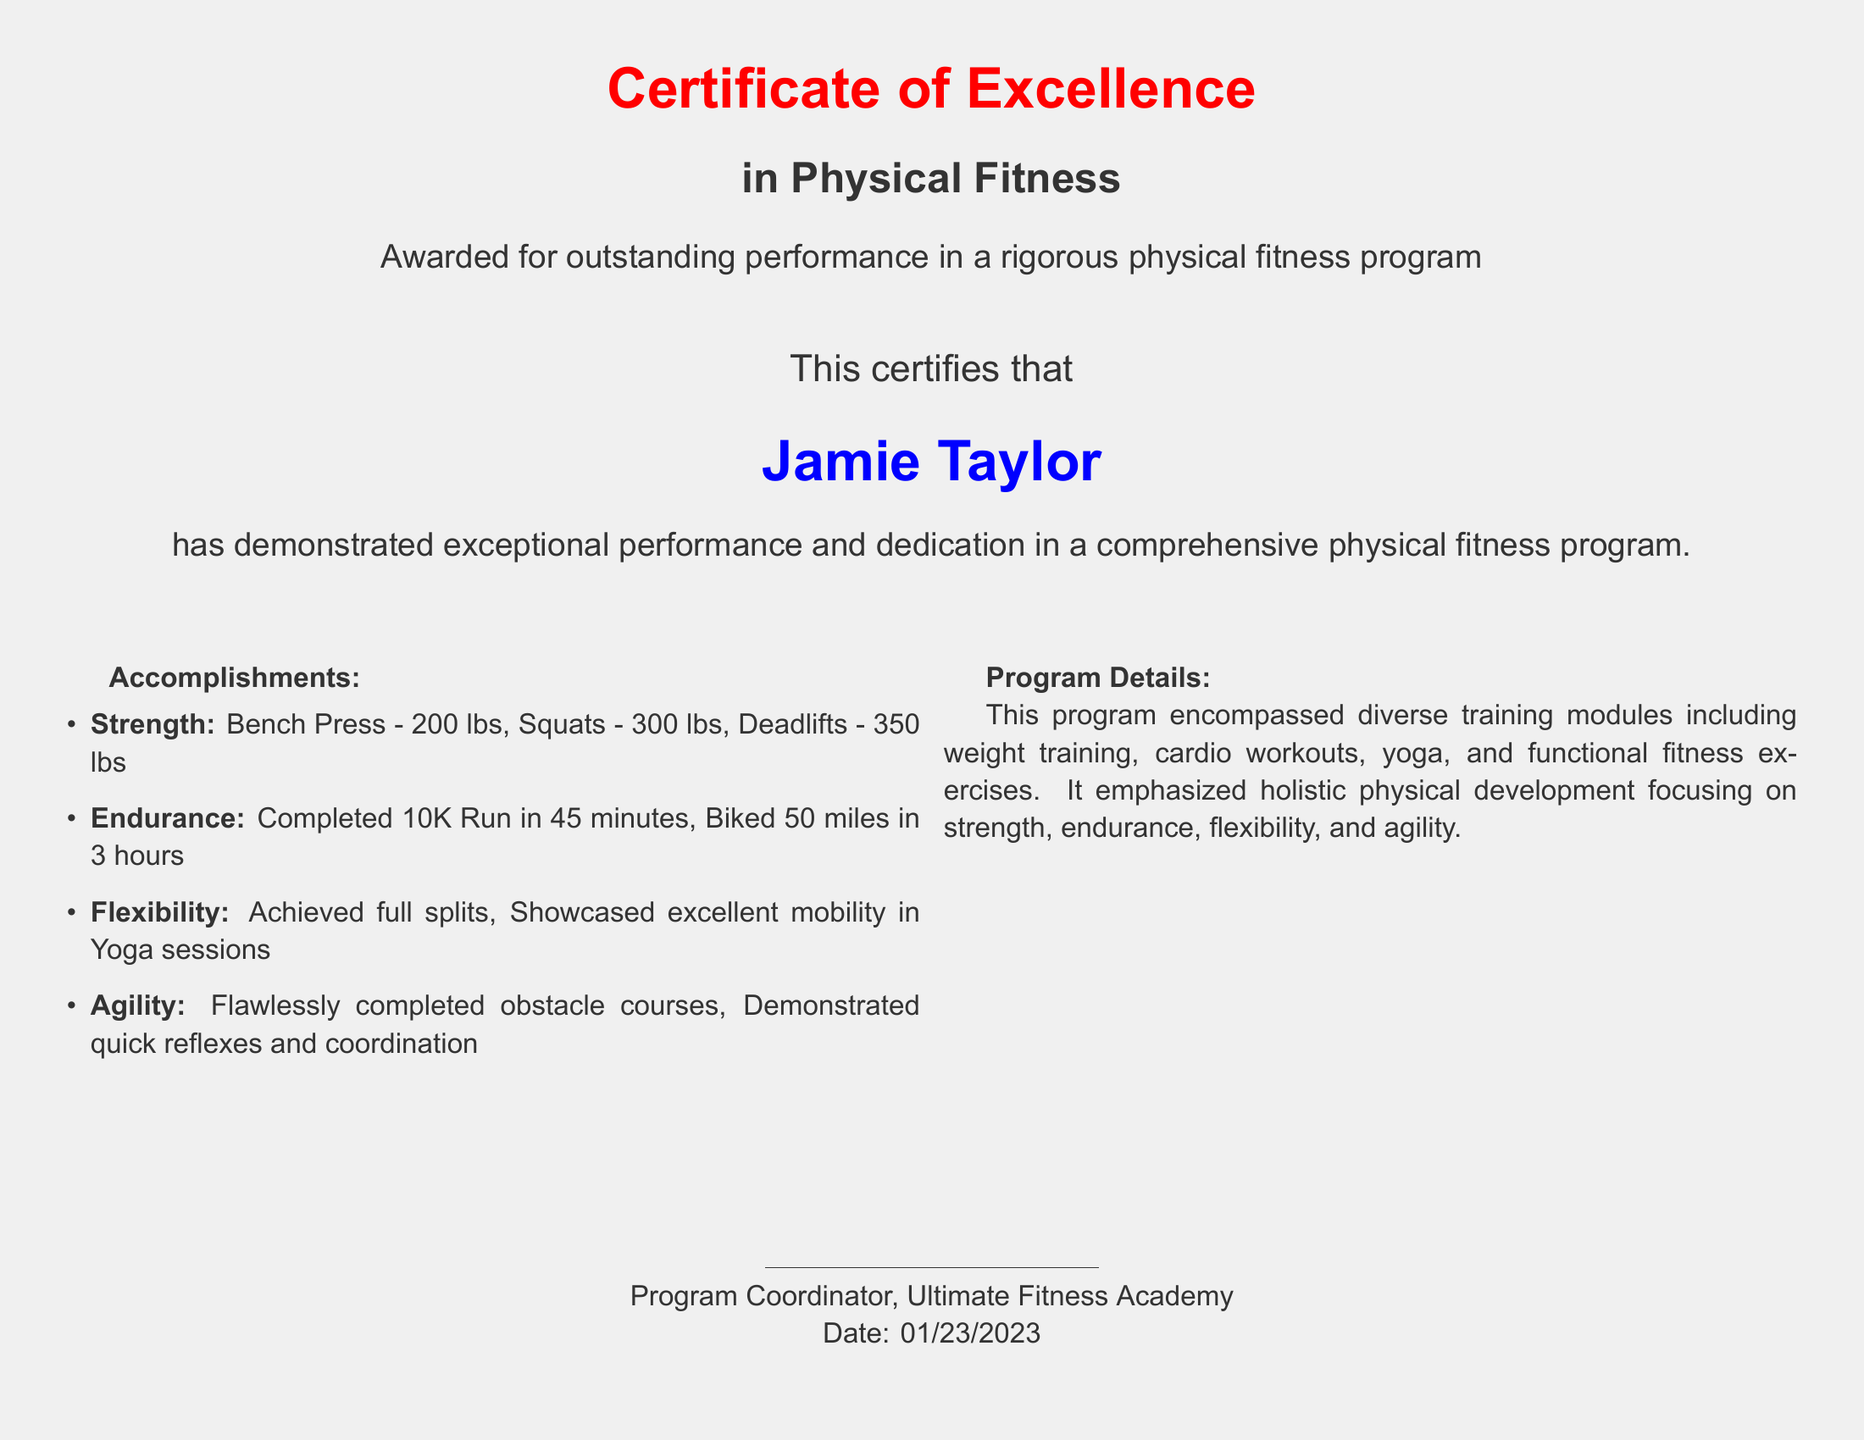what is the title of the certificate? The title of the certificate is prominently displayed at the top of the document, stating "Certificate of Excellence".
Answer: Certificate of Excellence who is the recipient of the certificate? The name of the recipient is clearly mentioned in a larger font, indicating who received the certificate.
Answer: Jamie Taylor when was the certificate awarded? The date of the award is listed prominently at the bottom of the document.
Answer: 01/23/2023 what is the total weight lifted in the deadlift? The specific accomplishment for deadlifts is noted in the accomplishments section of the document.
Answer: 350 lbs which event was completed in 45 minutes? The document includes specific accomplishments related to endurance, where the time for the event is mentioned.
Answer: 10K Run what physical fitness areas are highlighted in the program? The document outlines various aspects of physical fitness by categorizing them in the accomplishments section.
Answer: Strength, Endurance, Flexibility, Agility who coordinated the program? The name or title of the individual coordinating the program is noted at the bottom of the certificate.
Answer: Program Coordinator what type of training does the program encompass? The program details section lists various training modules included in the program.
Answer: Weight training, Cardio workouts, Yoga, Functional fitness exercises 